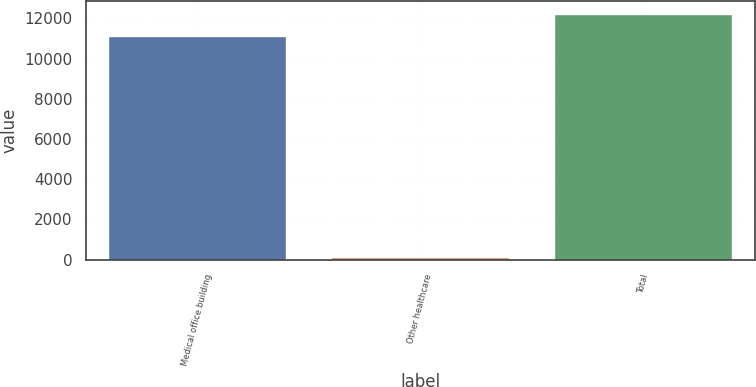Convert chart. <chart><loc_0><loc_0><loc_500><loc_500><bar_chart><fcel>Medical office building<fcel>Other healthcare<fcel>Total<nl><fcel>11134<fcel>123<fcel>12247.4<nl></chart> 